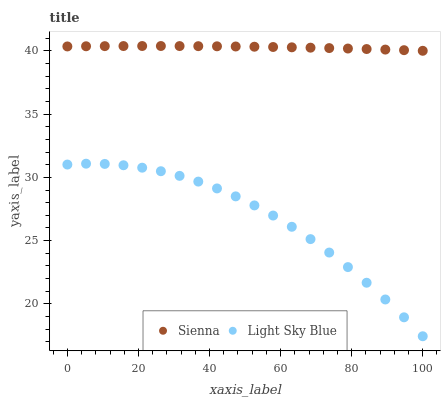Does Light Sky Blue have the minimum area under the curve?
Answer yes or no. Yes. Does Sienna have the maximum area under the curve?
Answer yes or no. Yes. Does Light Sky Blue have the maximum area under the curve?
Answer yes or no. No. Is Sienna the smoothest?
Answer yes or no. Yes. Is Light Sky Blue the roughest?
Answer yes or no. Yes. Is Light Sky Blue the smoothest?
Answer yes or no. No. Does Light Sky Blue have the lowest value?
Answer yes or no. Yes. Does Sienna have the highest value?
Answer yes or no. Yes. Does Light Sky Blue have the highest value?
Answer yes or no. No. Is Light Sky Blue less than Sienna?
Answer yes or no. Yes. Is Sienna greater than Light Sky Blue?
Answer yes or no. Yes. Does Light Sky Blue intersect Sienna?
Answer yes or no. No. 